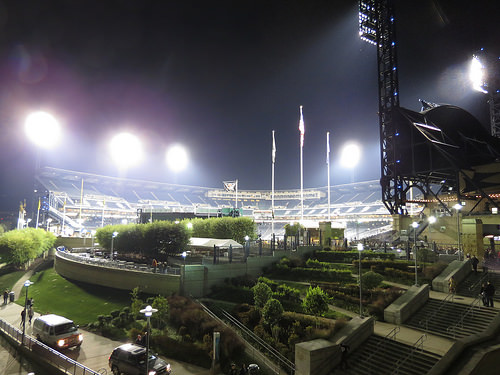<image>
Is there a sky behind the light? Yes. From this viewpoint, the sky is positioned behind the light, with the light partially or fully occluding the sky. 